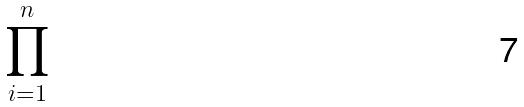Convert formula to latex. <formula><loc_0><loc_0><loc_500><loc_500>\prod _ { i = 1 } ^ { n }</formula> 